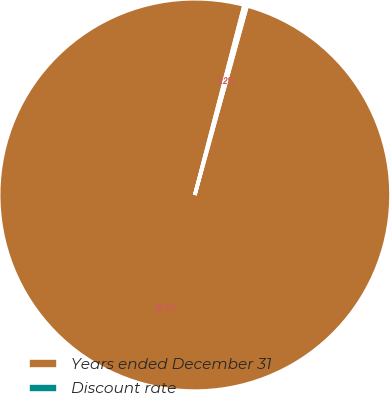Convert chart to OTSL. <chart><loc_0><loc_0><loc_500><loc_500><pie_chart><fcel>Years ended December 31<fcel>Discount rate<nl><fcel>99.75%<fcel>0.25%<nl></chart> 